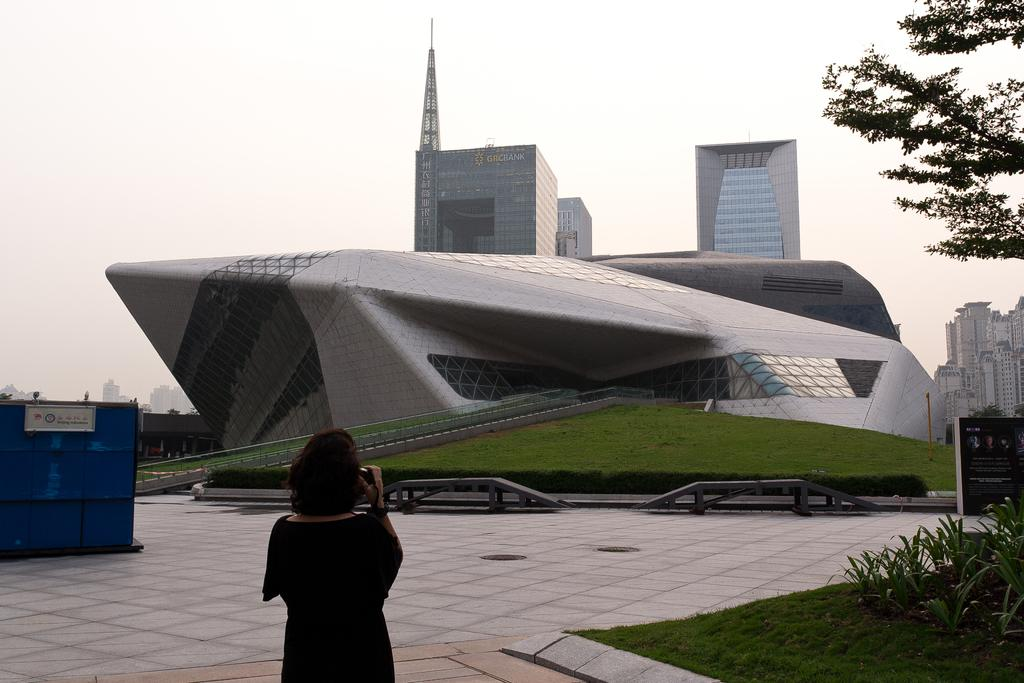What is the main subject in the center of the image? There is a building in the center of the image. What type of vegetation is present in the center of the image? There is grass in the center of the image. What can be seen in the background of the image? There are buildings visible in the background of the image, as well as the sky. Can you describe the person at the bottom of the image? There is a person at the bottom of the image. What is visible at the bottom of the image besides the person? There is ground, grass, and plants visible at the bottom of the image. Where is the vase of flowers located in the image? There is no vase of flowers present in the image. What type of bread can be seen in the image? There is no bread visible in the image. 